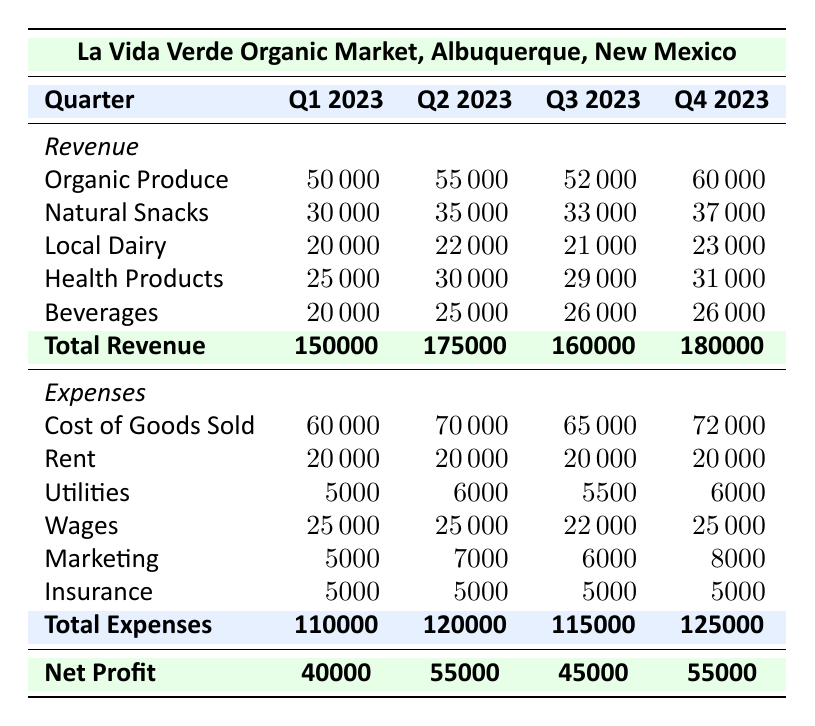What was the total revenue in Q2 2023? According to the table, the total revenue for Q2 2023 is explicitly listed as 175000.
Answer: 175000 What is the total expense for Q1 2023? The total expense for Q1 2023 is provided in the table as 110000.
Answer: 110000 How much did La Vida Verde Organic Market earn in net profit during Q3 2023? The net profit for Q3 2023 is indicated in the table as 45000.
Answer: 45000 Which quarter had the highest total revenue? By comparing the total revenue figures, Q4 2023 has the highest total revenue listed, which is 180000.
Answer: Q4 2023 What was the increase in total revenue from Q1 2023 to Q2 2023? To find the increase, subtract Q1’s revenue (150000) from Q2’s revenue (175000): 175000 - 150000 = 25000.
Answer: 25000 Was the expense for Cost of Goods Sold higher in Q4 2023 than in Q3 2023? Yes, Q4 2023 shows a Cost of Goods Sold of 72000, which is higher than Q3’s 65000.
Answer: Yes What is the average total revenue for the year 2023? Add the total revenue of all quarters (150000 + 175000 + 160000 + 180000 = 665000), then divide by 4 to find the average: 665000/4 = 166250.
Answer: 166250 In which quarter did the business spend the most on marketing? The marketing expense peaked in Q4 2023, where it is recorded as 8000, the highest among all quarters.
Answer: Q4 2023 What was the total expense for all four quarters combined? Adding the total expenses: 110000 (Q1) + 120000 (Q2) + 115000 (Q3) + 125000 (Q4) gives a total of 470000.
Answer: 470000 Which category had the lowest revenue in Q3 2023? In Q3 2023, the Local Dairy category had the lowest revenue, recorded at 21000.
Answer: Local Dairy What was the total net profit for the entire year 2023? First, calculate the net profits for each quarter: 40000 (Q1) + 55000 (Q2) + 45000 (Q3) + 55000 (Q4). The total net profit is 40000 + 55000 + 45000 + 55000 = 195000.
Answer: 195000 